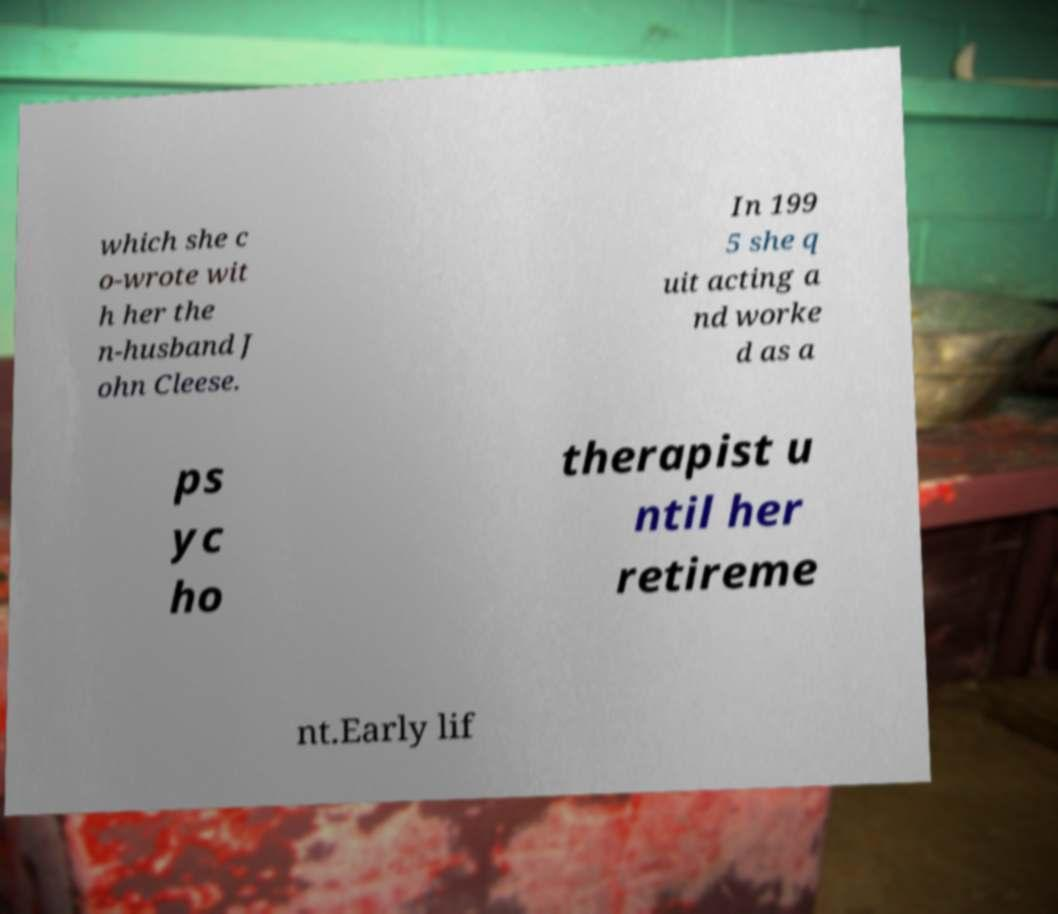Please identify and transcribe the text found in this image. which she c o-wrote wit h her the n-husband J ohn Cleese. In 199 5 she q uit acting a nd worke d as a ps yc ho therapist u ntil her retireme nt.Early lif 